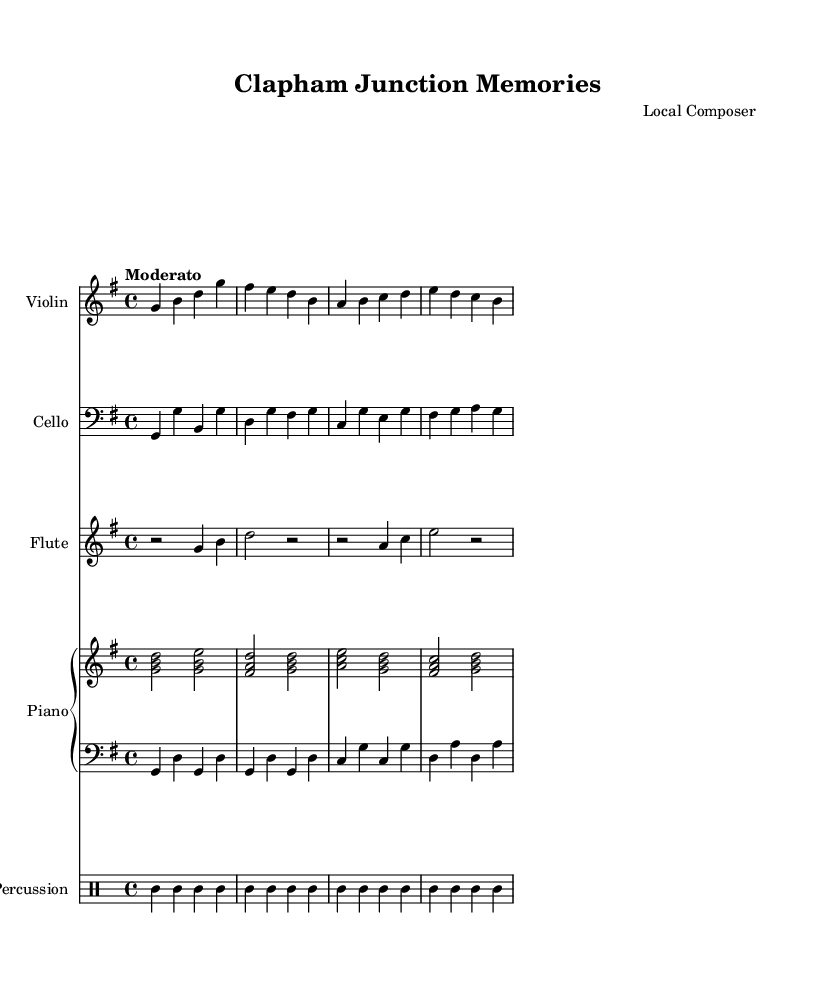What is the key signature of this music? The key signature shows one sharp, indicating it is in G major, which contains F#.
Answer: G major What is the time signature of this piece? The time signature is indicated as 4/4, meaning there are four beats per measure.
Answer: 4/4 What is the tempo marking for this score? The tempo marking is "Moderato," which suggests a moderate pace for the performance.
Answer: Moderato How many measures are in the Violin part? By counting the distinct measures in the Violin staff, there are 4 measures present.
Answer: 4 Which instrument has the clef shown as bass? The bass clef appears on the cello staff, identifying it as the instrument using the bass clef.
Answer: Cello What two percussion instruments are used in this score? The percussion part consists of triangle and tambourine, as specified in the percussion staff.
Answer: Triangle, tambourine How is the harmony structured in the upper piano staff? The upper staff parts are primarily structured with triads, emphasizing chordal harmonies built on notes like G, B, and D.
Answer: Triads 